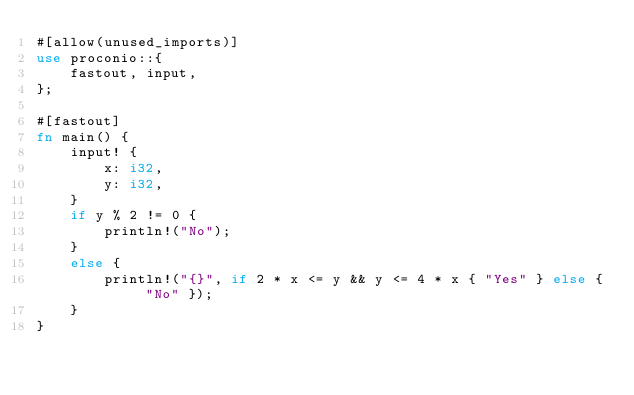<code> <loc_0><loc_0><loc_500><loc_500><_Rust_>#[allow(unused_imports)]
use proconio::{
    fastout, input,
};

#[fastout]
fn main() {
    input! {
        x: i32,
        y: i32,
    }
    if y % 2 != 0 {
        println!("No");
    }
    else {
        println!("{}", if 2 * x <= y && y <= 4 * x { "Yes" } else { "No" });
    }
}
</code> 